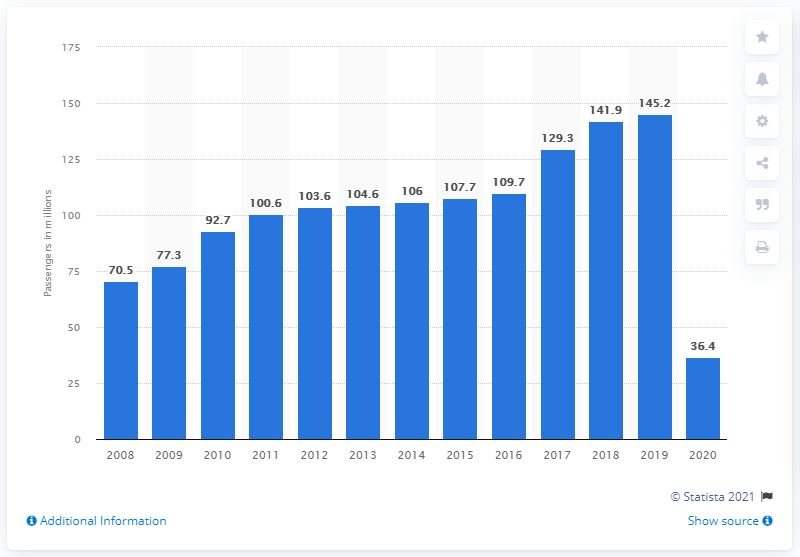Specify some key components in this picture. Lufthansa transported a total of 36.4 million passengers in 2020. In the previous year, Lufthansa transported 145,200 passengers. 